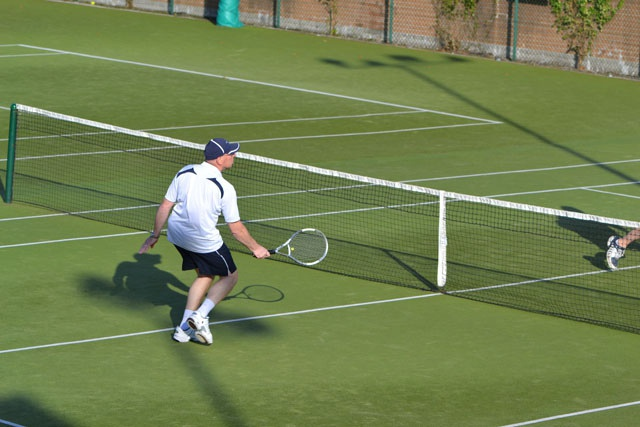Describe the objects in this image and their specific colors. I can see people in olive, lavender, black, gray, and lightpink tones, tennis racket in olive, gray, darkgray, and darkgreen tones, and people in olive, gray, lightgray, darkgray, and black tones in this image. 